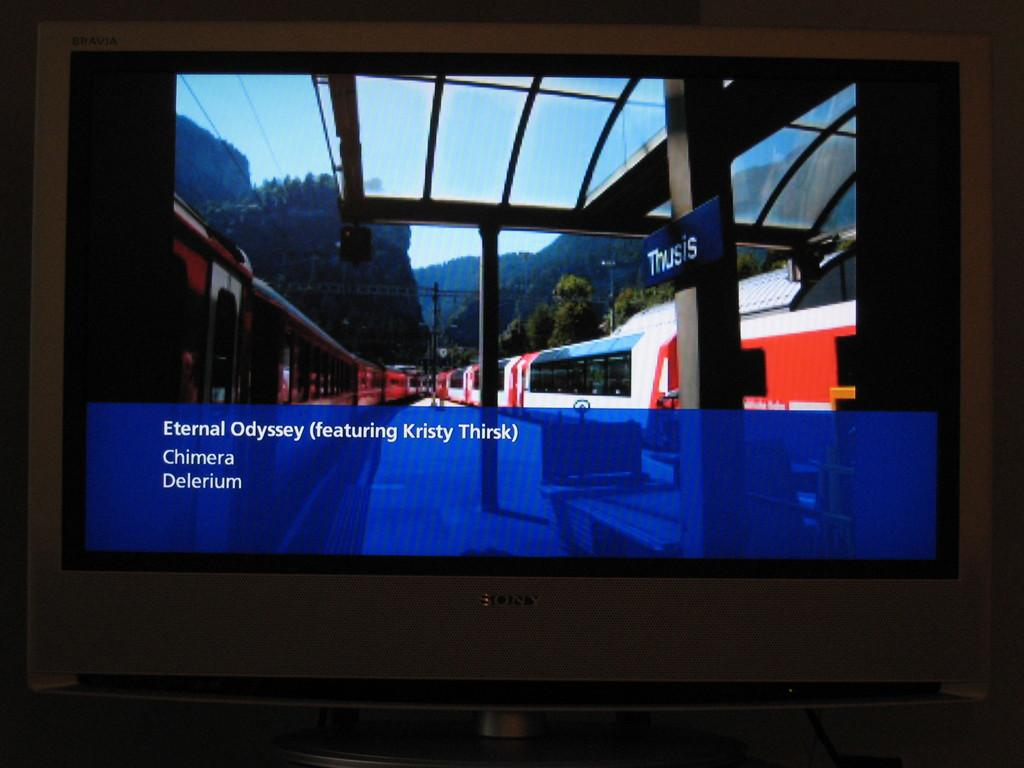Provide a one-sentence caption for the provided image. A picture of a train with the words Eternal Odyssey under it. 